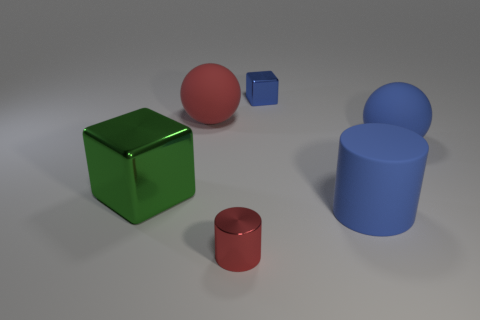Add 2 large rubber objects. How many objects exist? 8 Subtract all cubes. How many objects are left? 4 Subtract all big green blocks. Subtract all tiny shiny cubes. How many objects are left? 4 Add 4 green metallic cubes. How many green metallic cubes are left? 5 Add 5 big blocks. How many big blocks exist? 6 Subtract 0 brown blocks. How many objects are left? 6 